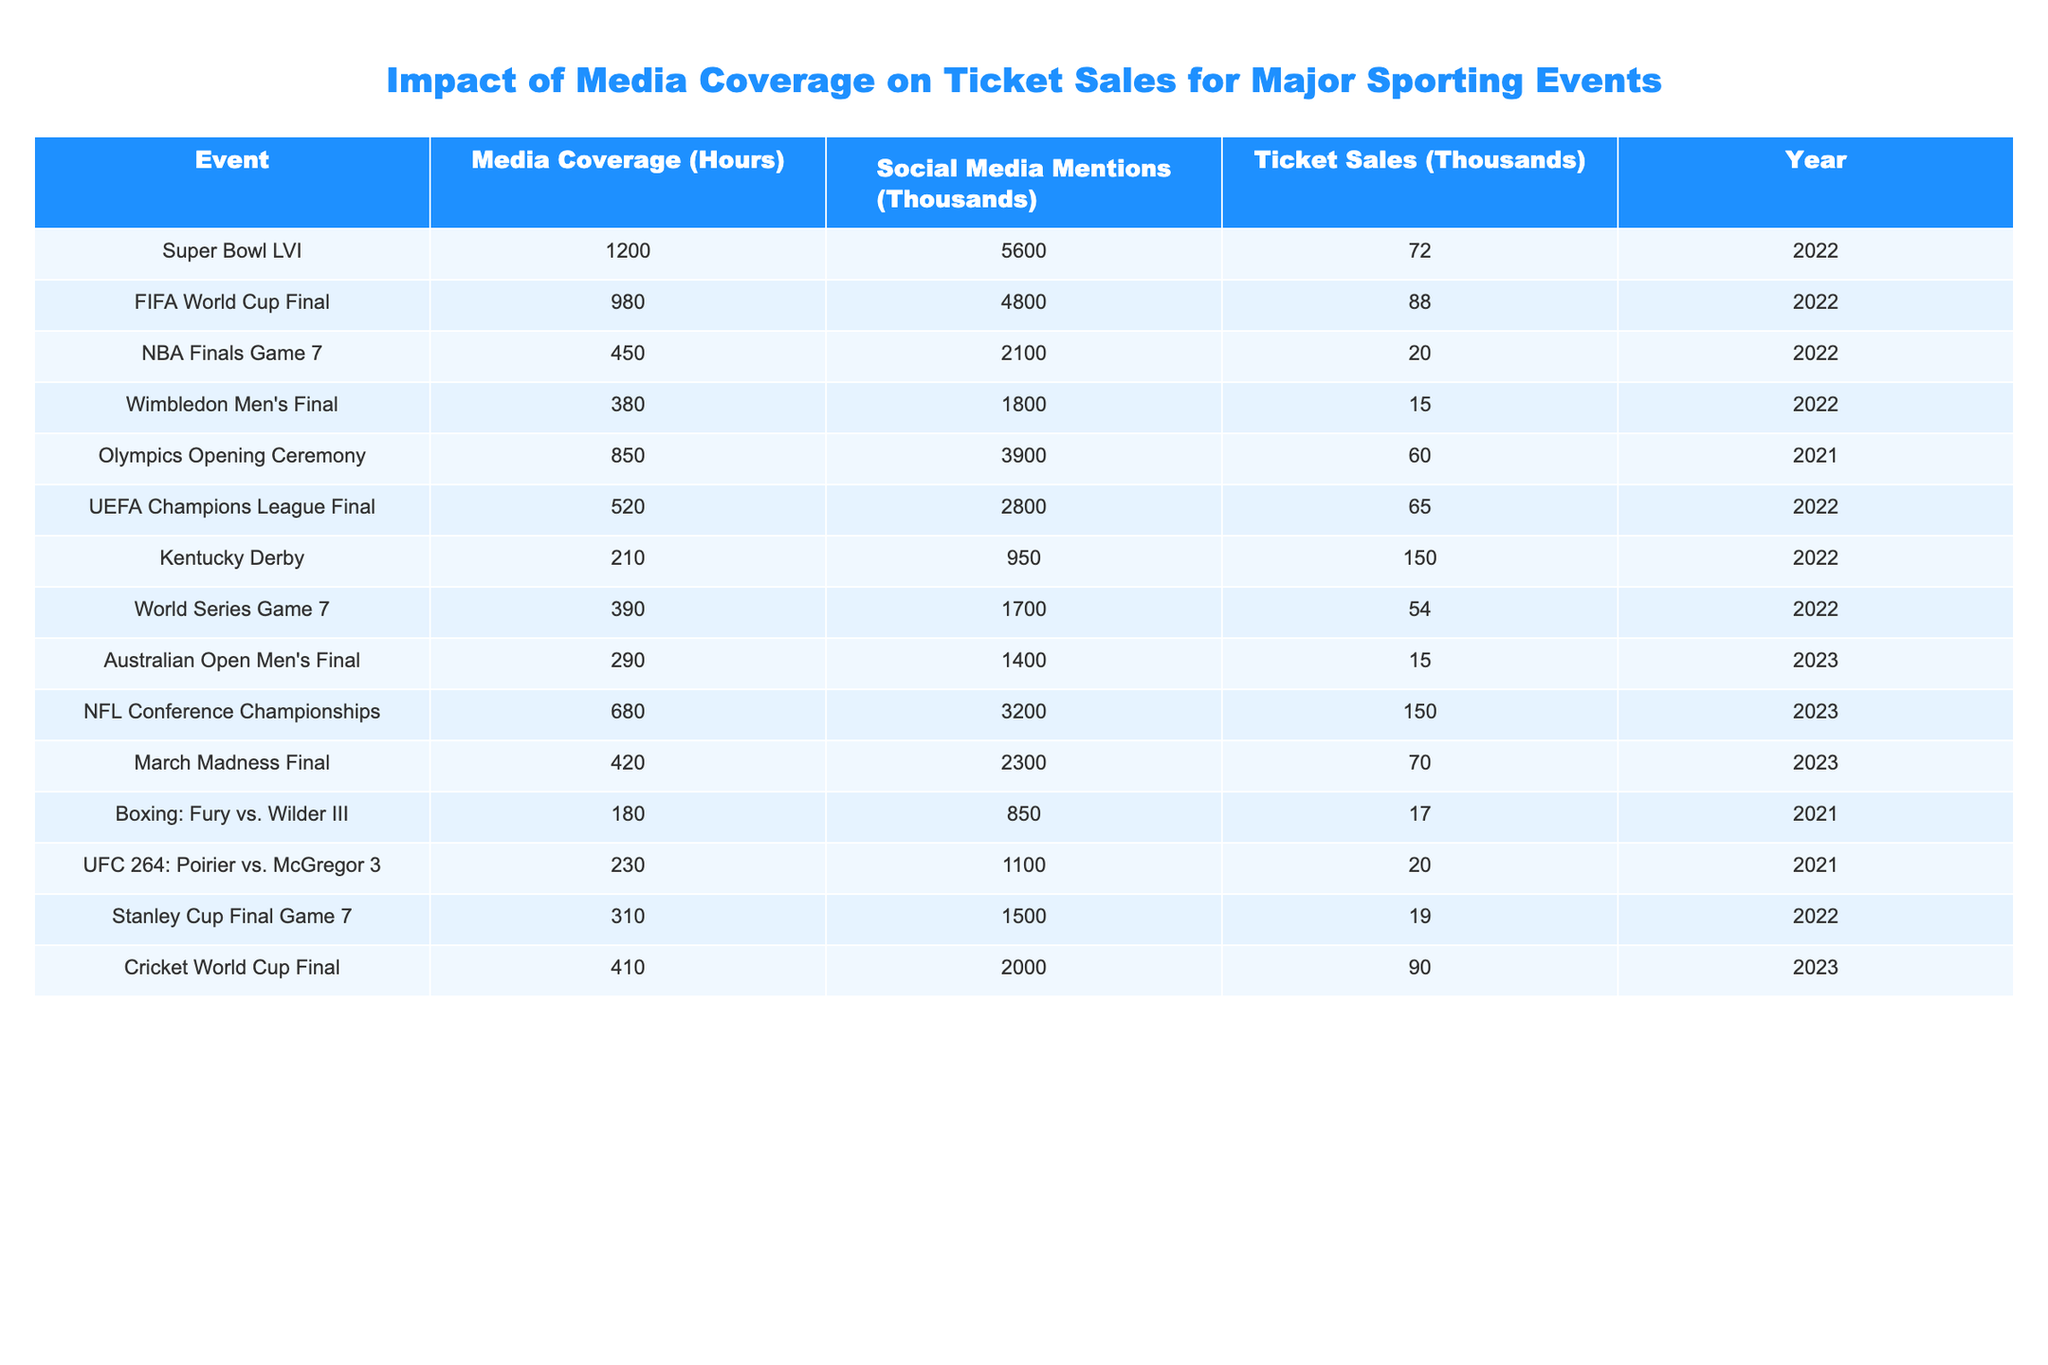What is the highest ticket sales recorded in the table? The ticket sales values are 72, 88, 20, 15, 60, 65, 150, 54, 15, 150, 70, 17, 20, 19, and 90. The highest among these is 150.
Answer: 150 Which event had the most media coverage in hours? The media coverage values are 1200, 980, 450, 380, 850, 520, 210, 390, 290, 680, 420, 180, 230, 310, and 410. The highest value is 1200 hours for the Super Bowl LVI.
Answer: 1200 How many total ticket sales were recorded for events in 2022? The ticket sales for 2022 events are 72, 88, 20, 15, 60, 65, 150, and 54. Summing these gives 72 + 88 + 20 + 15 + 60 + 65 + 150 + 54 = 454.
Answer: 454 What percentage of social media mentions did the Super Bowl LVI have compared to the FIFA World Cup Final? The social media mentions for Super Bowl LVI are 5600, and for FIFA World Cup Final, it is 4800. To find the percentage: (5600 / 4800) * 100 = 116.67%.
Answer: 116.67% Is it true that the Kentucky Derby had more ticket sales than the Wimbledon Men's Final? The ticket sales for the Kentucky Derby are 150, while for Wimbledon Men's Final, it's 15. Since 150 is greater than 15, the statement is true.
Answer: Yes What is the average media coverage for all events listed? To find the average, sum all media coverage hours: 1200 + 980 + 450 + 380 + 850 + 520 + 210 + 390 + 290 + 680 + 420 + 180 + 230 + 310 + 410 =  7110. There are 15 events, so the average is 7110 / 15 = 474.
Answer: 474 Which event had the lowest social media mentions? The social media mentions are 5600, 4800, 2100, 1800, 3900, 2800, 950, 1700, 1400, 3200, 2300, 850, 1100, 1500, and 2000. The lowest is 850 for the boxing match.
Answer: 850 If you were to combine the ticket sales of the NBA Finals Game 7 and the Stanley Cup Final Game 7, how many ticket sales would that yield? The ticket sales for NBA Finals Game 7 is 20 and Stanley Cup Final Game 7 is 19. Adding these gives 20 + 19 = 39.
Answer: 39 In which year did the Cricket World Cup Final take place? Looking at the table, the recorded year for the Cricket World Cup Final is 2023.
Answer: 2023 What is the difference in ticket sales between the UFC 264 event and the March Madness Final? The ticket sales for UFC 264 is 20, and for March Madness Final, it is 70. The difference is 70 - 20 = 50.
Answer: 50 